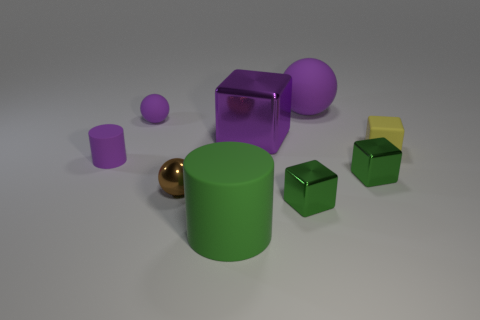Can you tell me which object stands out the most in this image and why? The reflective gold sphere stands out due to its unique color and sheen, which contrasts with the matte textures of the other objects and catches the light differently.  If you had to guess, what material do you think these objects are made of? Based on their appearance, the objects could be made of plastic or some other synthetic material, as indicated by the uniform colors and smooth surfaces. 